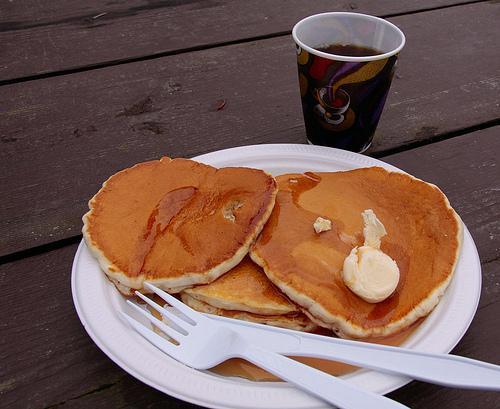How many pancakes are there?
Give a very brief answer. 4. 